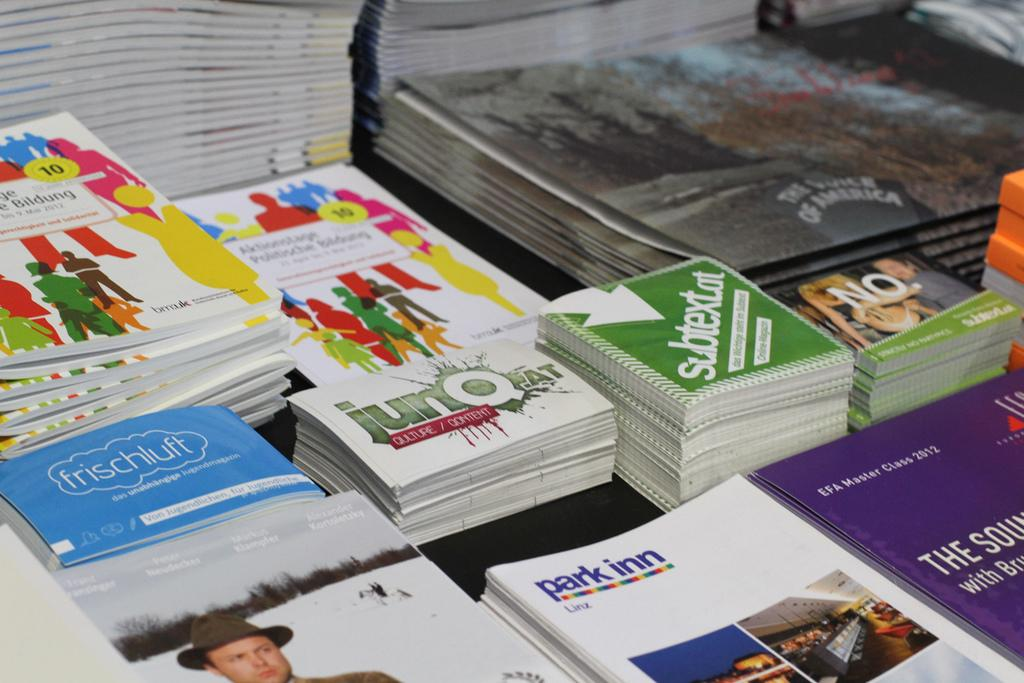<image>
Present a compact description of the photo's key features. A blue book says frischulft on the cover, inside the outline of a cloud. 